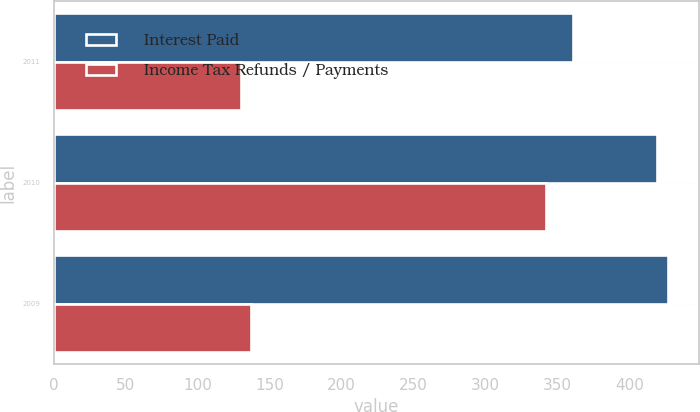Convert chart to OTSL. <chart><loc_0><loc_0><loc_500><loc_500><stacked_bar_chart><ecel><fcel>2011<fcel>2010<fcel>2009<nl><fcel>Interest Paid<fcel>361<fcel>419<fcel>427<nl><fcel>Income Tax Refunds / Payments<fcel>130<fcel>342<fcel>137<nl></chart> 